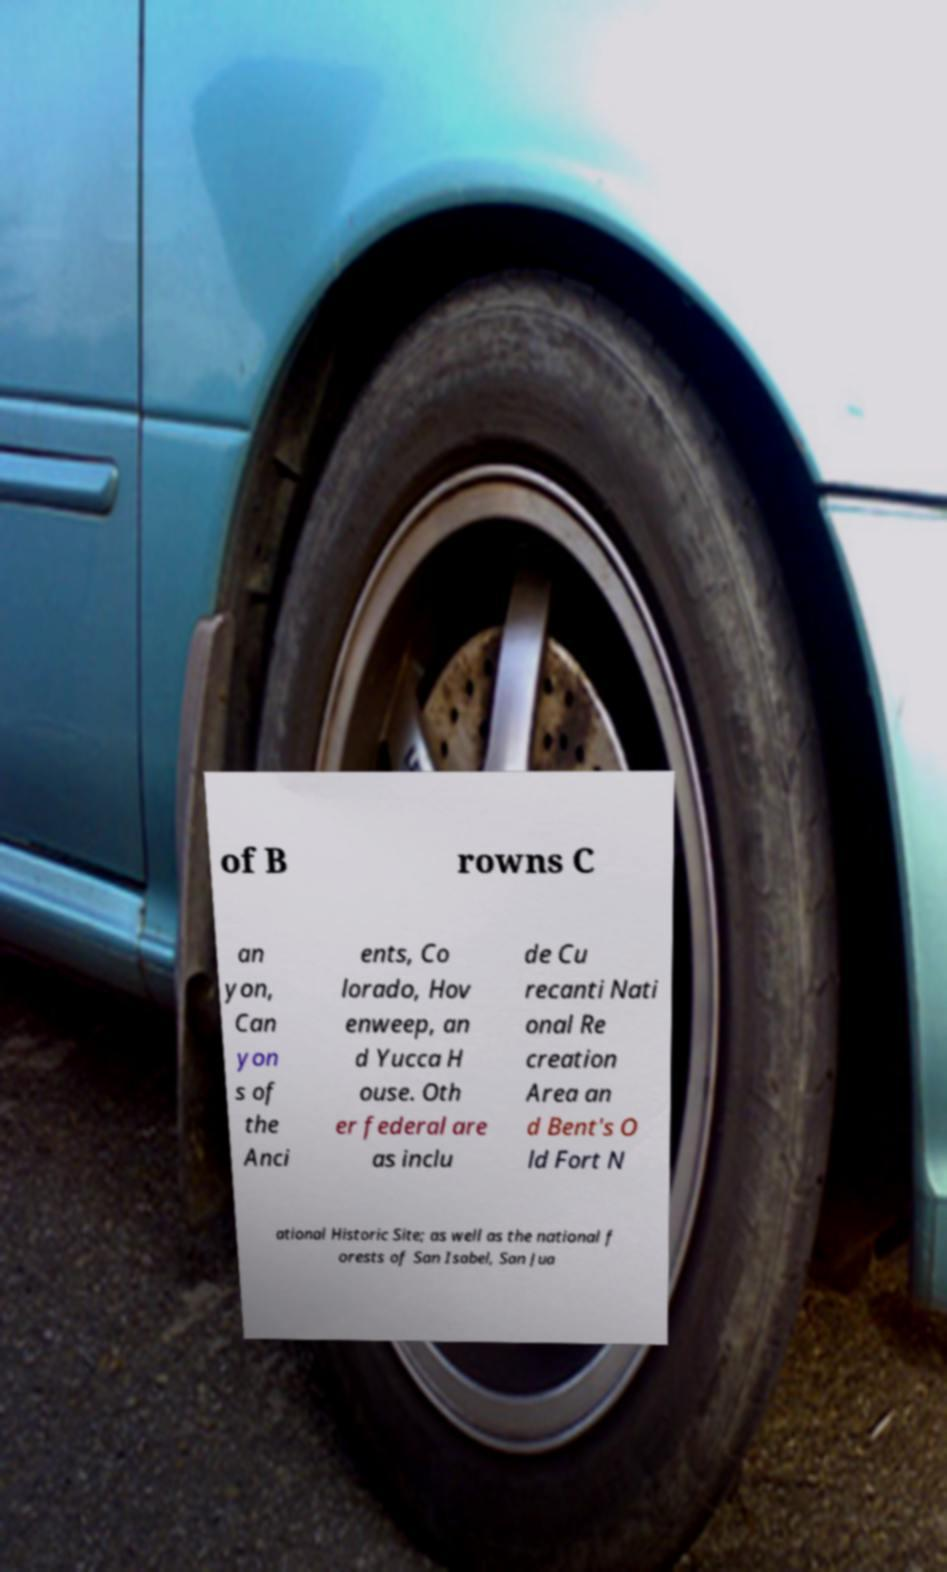There's text embedded in this image that I need extracted. Can you transcribe it verbatim? of B rowns C an yon, Can yon s of the Anci ents, Co lorado, Hov enweep, an d Yucca H ouse. Oth er federal are as inclu de Cu recanti Nati onal Re creation Area an d Bent's O ld Fort N ational Historic Site; as well as the national f orests of San Isabel, San Jua 